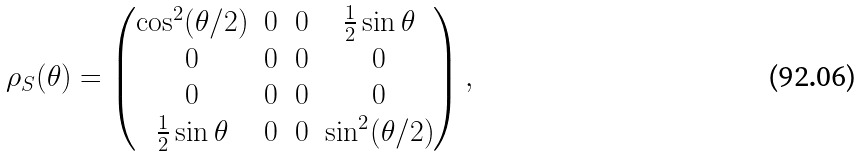<formula> <loc_0><loc_0><loc_500><loc_500>\rho _ { S } ( \theta ) = \begin{pmatrix} \cos ^ { 2 } ( \theta / 2 ) & 0 & 0 & \frac { 1 } { 2 } \sin \theta \\ 0 & 0 & 0 & 0 \\ 0 & 0 & 0 & 0 \\ \frac { 1 } { 2 } \sin \theta & 0 & 0 & \sin ^ { 2 } ( \theta / 2 ) \end{pmatrix} ,</formula> 